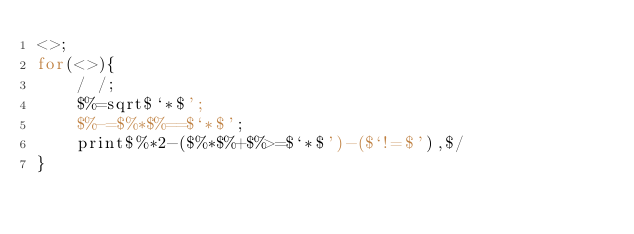Convert code to text. <code><loc_0><loc_0><loc_500><loc_500><_Perl_><>;
for(<>){
	/ /;
	$%=sqrt$`*$';
	$%-=$%*$%==$`*$';
	print$%*2-($%*$%+$%>=$`*$')-($`!=$'),$/
}
</code> 